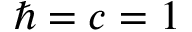Convert formula to latex. <formula><loc_0><loc_0><loc_500><loc_500>\hbar { = } c = 1</formula> 